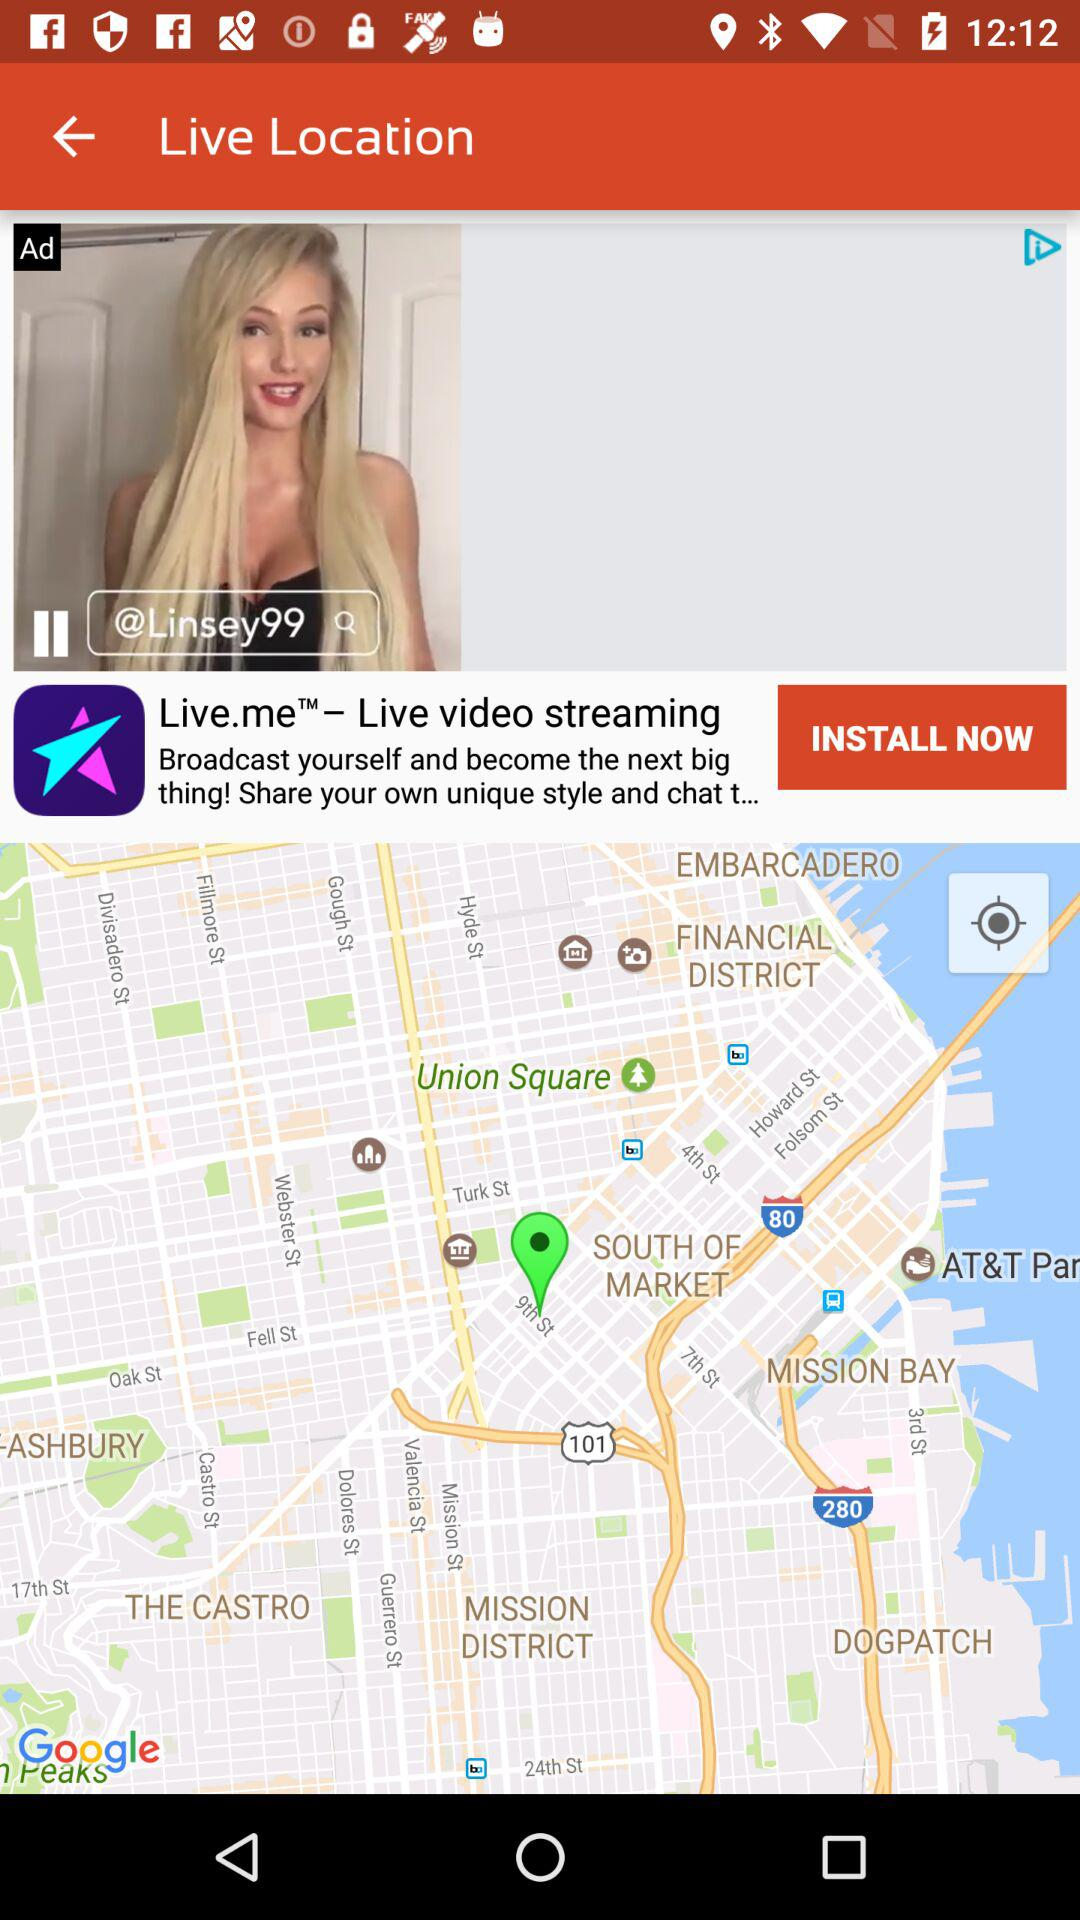What is the username? The username is "@Linsey99". 